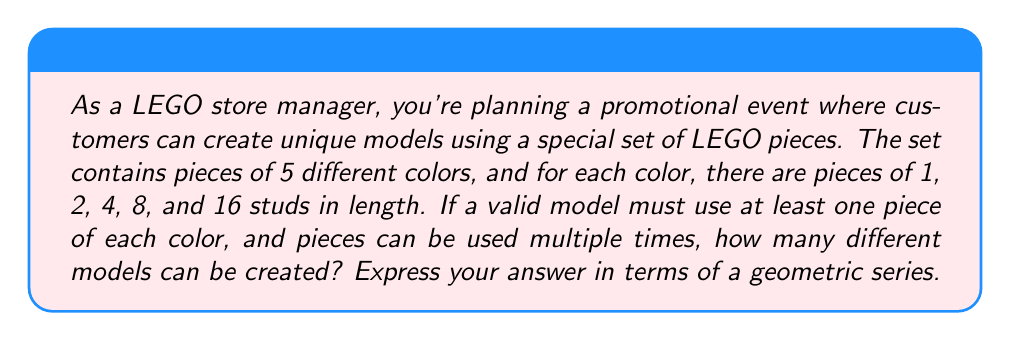Could you help me with this problem? Let's approach this step-by-step:

1) For each color, we need to determine how many combinations of pieces we can use. Since pieces can be used multiple times, and we must use at least one piece, we can think of this as choosing from 5 options (1, 2, 4, 8, or 16 studs) with replacement, but excluding the case where we choose none.

2) The number of ways to choose pieces of one color can be represented as:

   $$(1 + 1 + 1 + 1 + 1)^n - 1 = 5^n - 1$$

   where $n$ is the number of pieces we choose.

3) Since $n$ can be any positive integer, the total number of combinations for one color is:

   $$\sum_{n=1}^{\infty} (5^n - 1) = \sum_{n=1}^{\infty} 5^n - \sum_{n=1}^{\infty} 1$$

4) The first sum is a geometric series with first term $a=5$ and common ratio $r=5$. The sum of this infinite geometric series is:

   $$\sum_{n=1}^{\infty} 5^n = \frac{a}{1-r} = \frac{5}{1-5} = -\frac{5}{4}$$

5) The second sum is divergent, but we can represent it symbolically as $\infty$.

6) So, for each color, we have $-\frac{5}{4} - \infty$ combinations.

7) Since we need to use all 5 colors, we multiply this result by itself 5 times:

   $$(-\frac{5}{4} - \infty)^5$$

8) This expression represents the total number of possible models.
Answer: $$(-\frac{5}{4} - \infty)^5$$ 